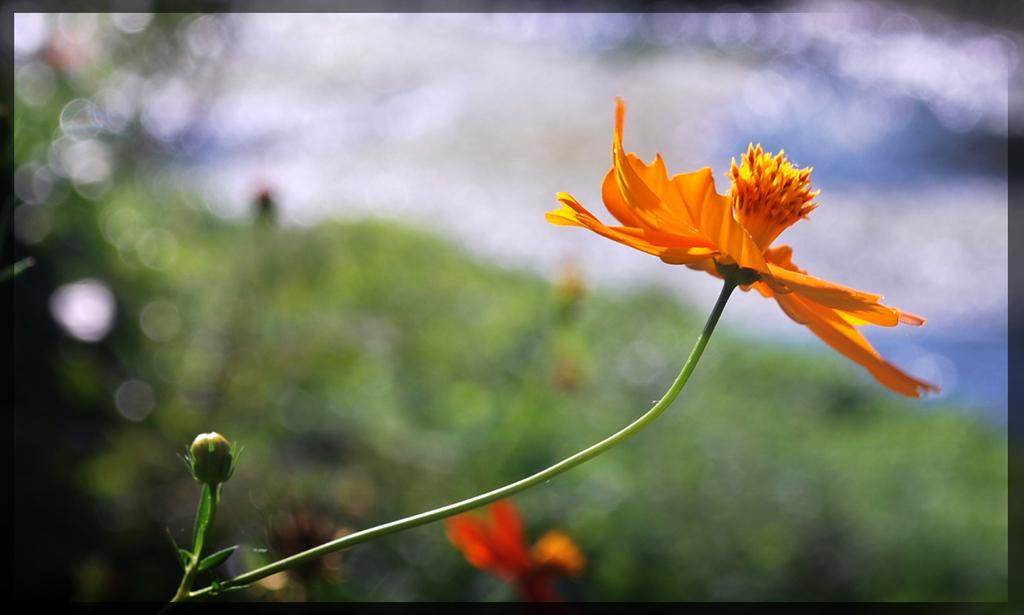What is the main subject of the image? There is a flower in the image. Can you describe the color of the flower? The flower is orange in color. What colors can be seen in the background of the image? The background of the image is white and green. Is there a swing visible in the image? No, there is no swing present in the image. 